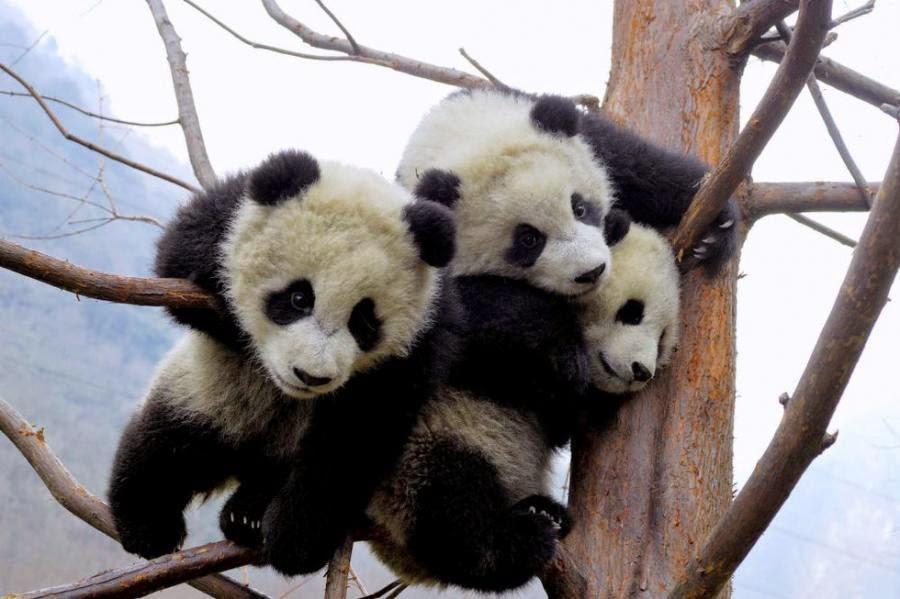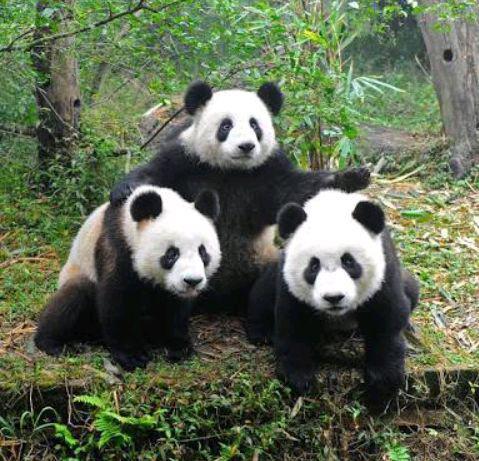The first image is the image on the left, the second image is the image on the right. For the images shown, is this caption "There are atleast 2 pandas in a tree" true? Answer yes or no. Yes. The first image is the image on the left, the second image is the image on the right. For the images shown, is this caption "Each image shows a trio of pandas grouped closed together, and the right image shows pandas forming a pyramid shape on a ground of greenery." true? Answer yes or no. Yes. 